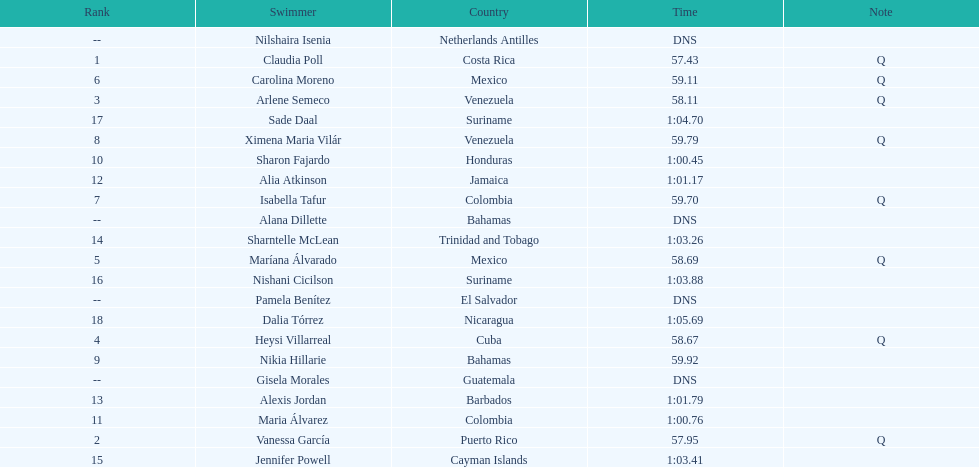Who was the only cuban to finish in the top eight? Heysi Villarreal. 